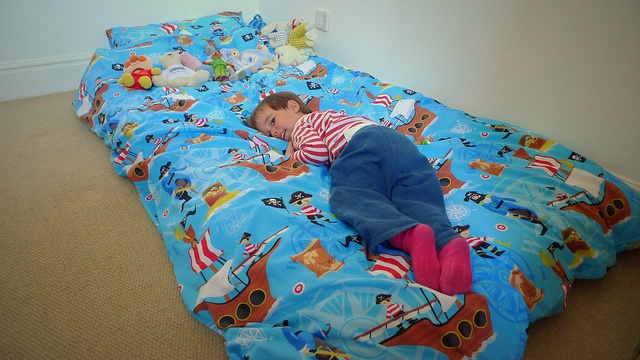Describe the objects in this image and their specific colors. I can see bed in darkgray, lightblue, and teal tones, people in darkgray, blue, navy, and brown tones, teddy bear in darkgray and lightgray tones, teddy bear in darkgray, olive, tan, and brown tones, and teddy bear in darkgray, lightblue, and lightgray tones in this image. 